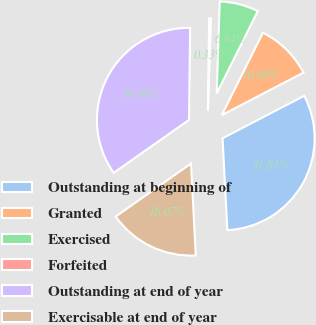Convert chart to OTSL. <chart><loc_0><loc_0><loc_500><loc_500><pie_chart><fcel>Outstanding at beginning of<fcel>Granted<fcel>Exercised<fcel>Forfeited<fcel>Outstanding at end of year<fcel>Exercisable at end of year<nl><fcel>31.81%<fcel>10.0%<fcel>6.84%<fcel>0.33%<fcel>34.96%<fcel>16.07%<nl></chart> 